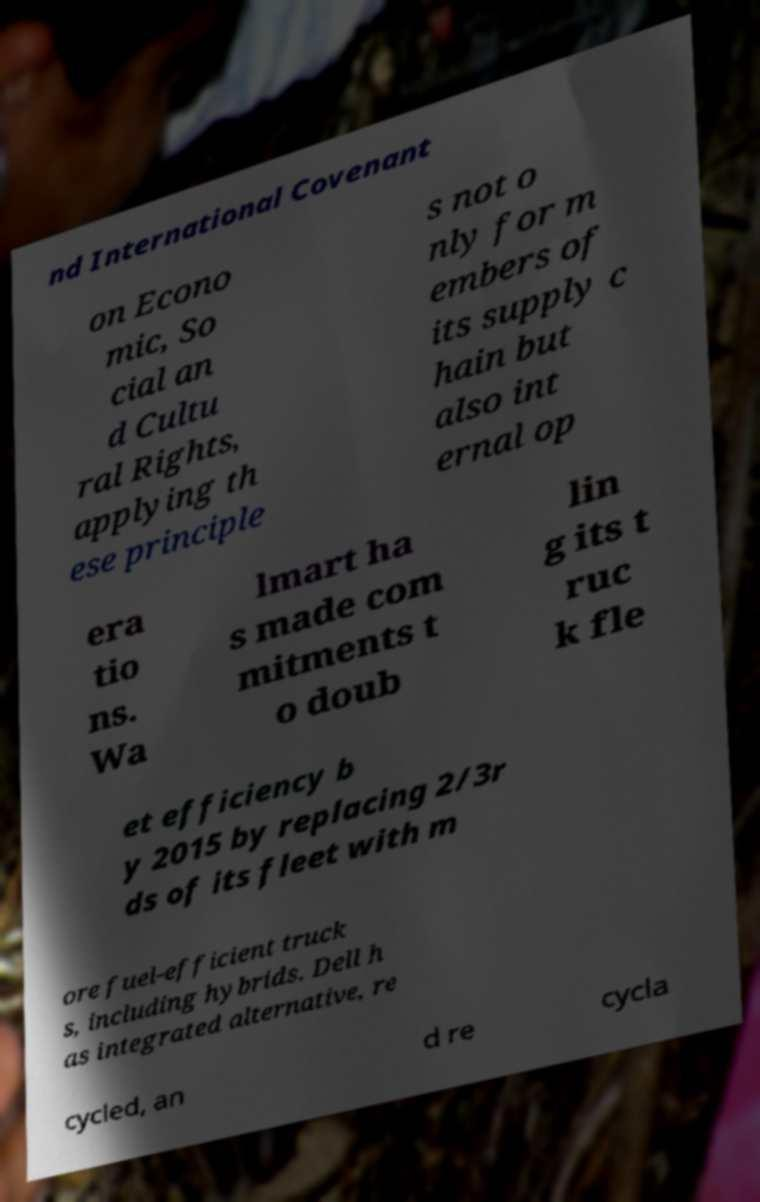Can you accurately transcribe the text from the provided image for me? nd International Covenant on Econo mic, So cial an d Cultu ral Rights, applying th ese principle s not o nly for m embers of its supply c hain but also int ernal op era tio ns. Wa lmart ha s made com mitments t o doub lin g its t ruc k fle et efficiency b y 2015 by replacing 2/3r ds of its fleet with m ore fuel-efficient truck s, including hybrids. Dell h as integrated alternative, re cycled, an d re cycla 